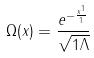Convert formula to latex. <formula><loc_0><loc_0><loc_500><loc_500>\Omega ( x ) = \frac { e ^ { - \frac { x ^ { 1 } } { 1 } } } { \sqrt { 1 \Lambda } }</formula> 